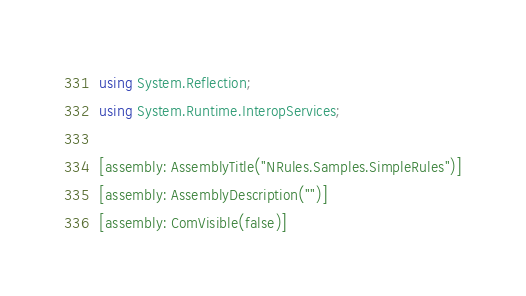<code> <loc_0><loc_0><loc_500><loc_500><_C#_>using System.Reflection;
using System.Runtime.InteropServices;

[assembly: AssemblyTitle("NRules.Samples.SimpleRules")]
[assembly: AssemblyDescription("")]
[assembly: ComVisible(false)]
</code> 